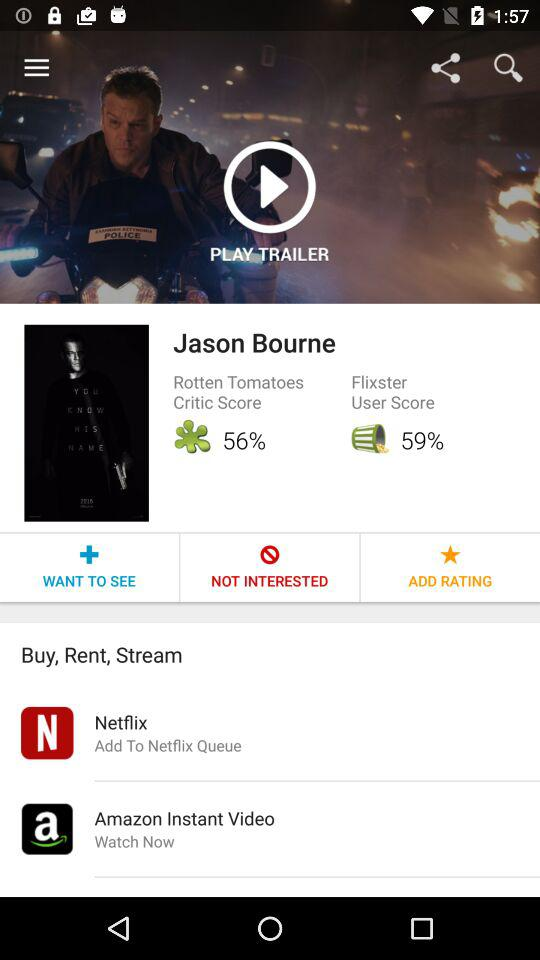What is the difference between the Rotten Tomatoes Critic Score and the Flixster User Score?
Answer the question using a single word or phrase. 3% 